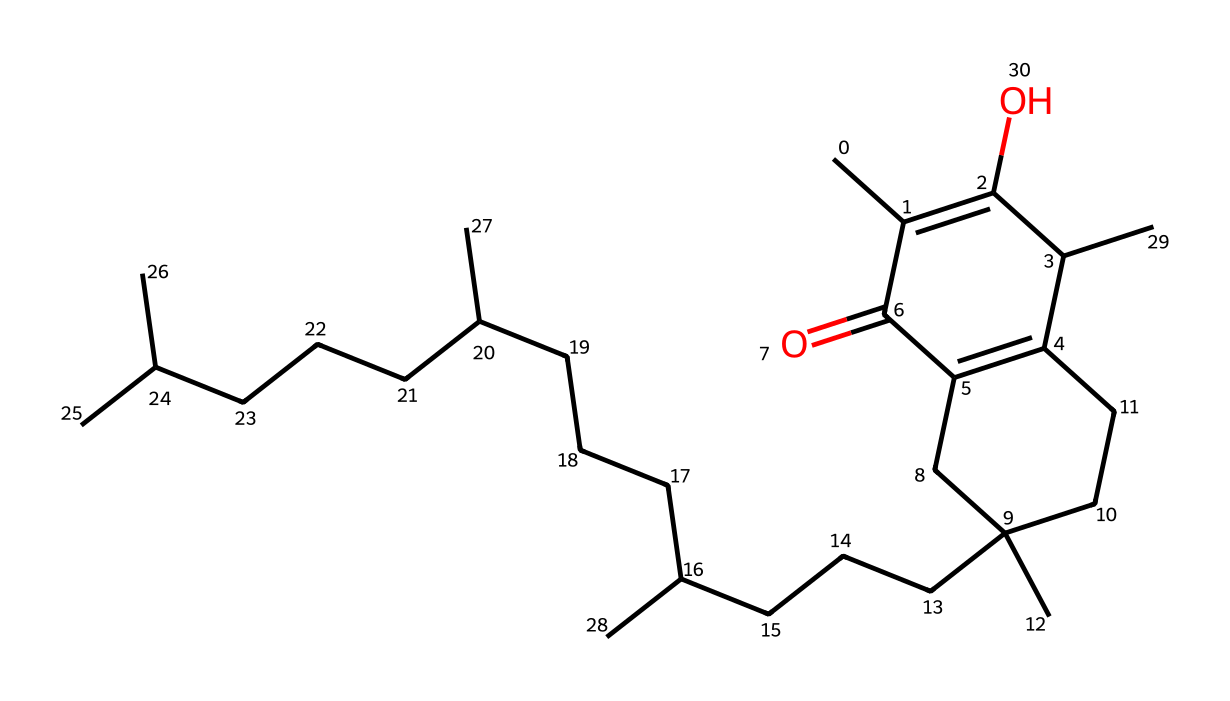How many carbon atoms are present in this molecule? The provided SMILES representation can be parsed to count the carbon atoms. Each 'C' denotes a carbon atom. Upon counting, there are 29 carbon atoms in the structure.
Answer: 29 What functional group is present in the molecule? By analyzing the structure in the SMILES, we can identify the presence of a hydroxyl group (-OH) indicated by an 'O' directly connected to a carbon. This suggests the presence of an alcohol functional group.
Answer: alcohol What is the name of this vitamin? The chemical structure corresponds to tocopherol, commonly known as vitamin E. This identification can be made based on the knowledge of vitamin E's typical chemical structure.
Answer: tocopherol How many double bonds are in the molecule? Examining the SMILES representation reveals two '=' signs which indicate the presence of double bonds. Counting these, we find that there are two double bonds in the structure.
Answer: 2 Which element is represented by 'O' in the structure? In the context of the SMILES notation, 'O' represents oxygen atoms. These are essential for the functional group characteristics of this vitamin, contributing to its biological activity.
Answer: oxygen What type of molecule is this? This structure is classified as a vitamin, as it signifies an organic compound necessary in small quantities for proper health. Specifically, this type is categorized under lipophilic vitamins due to its solubility in fats.
Answer: vitamin 